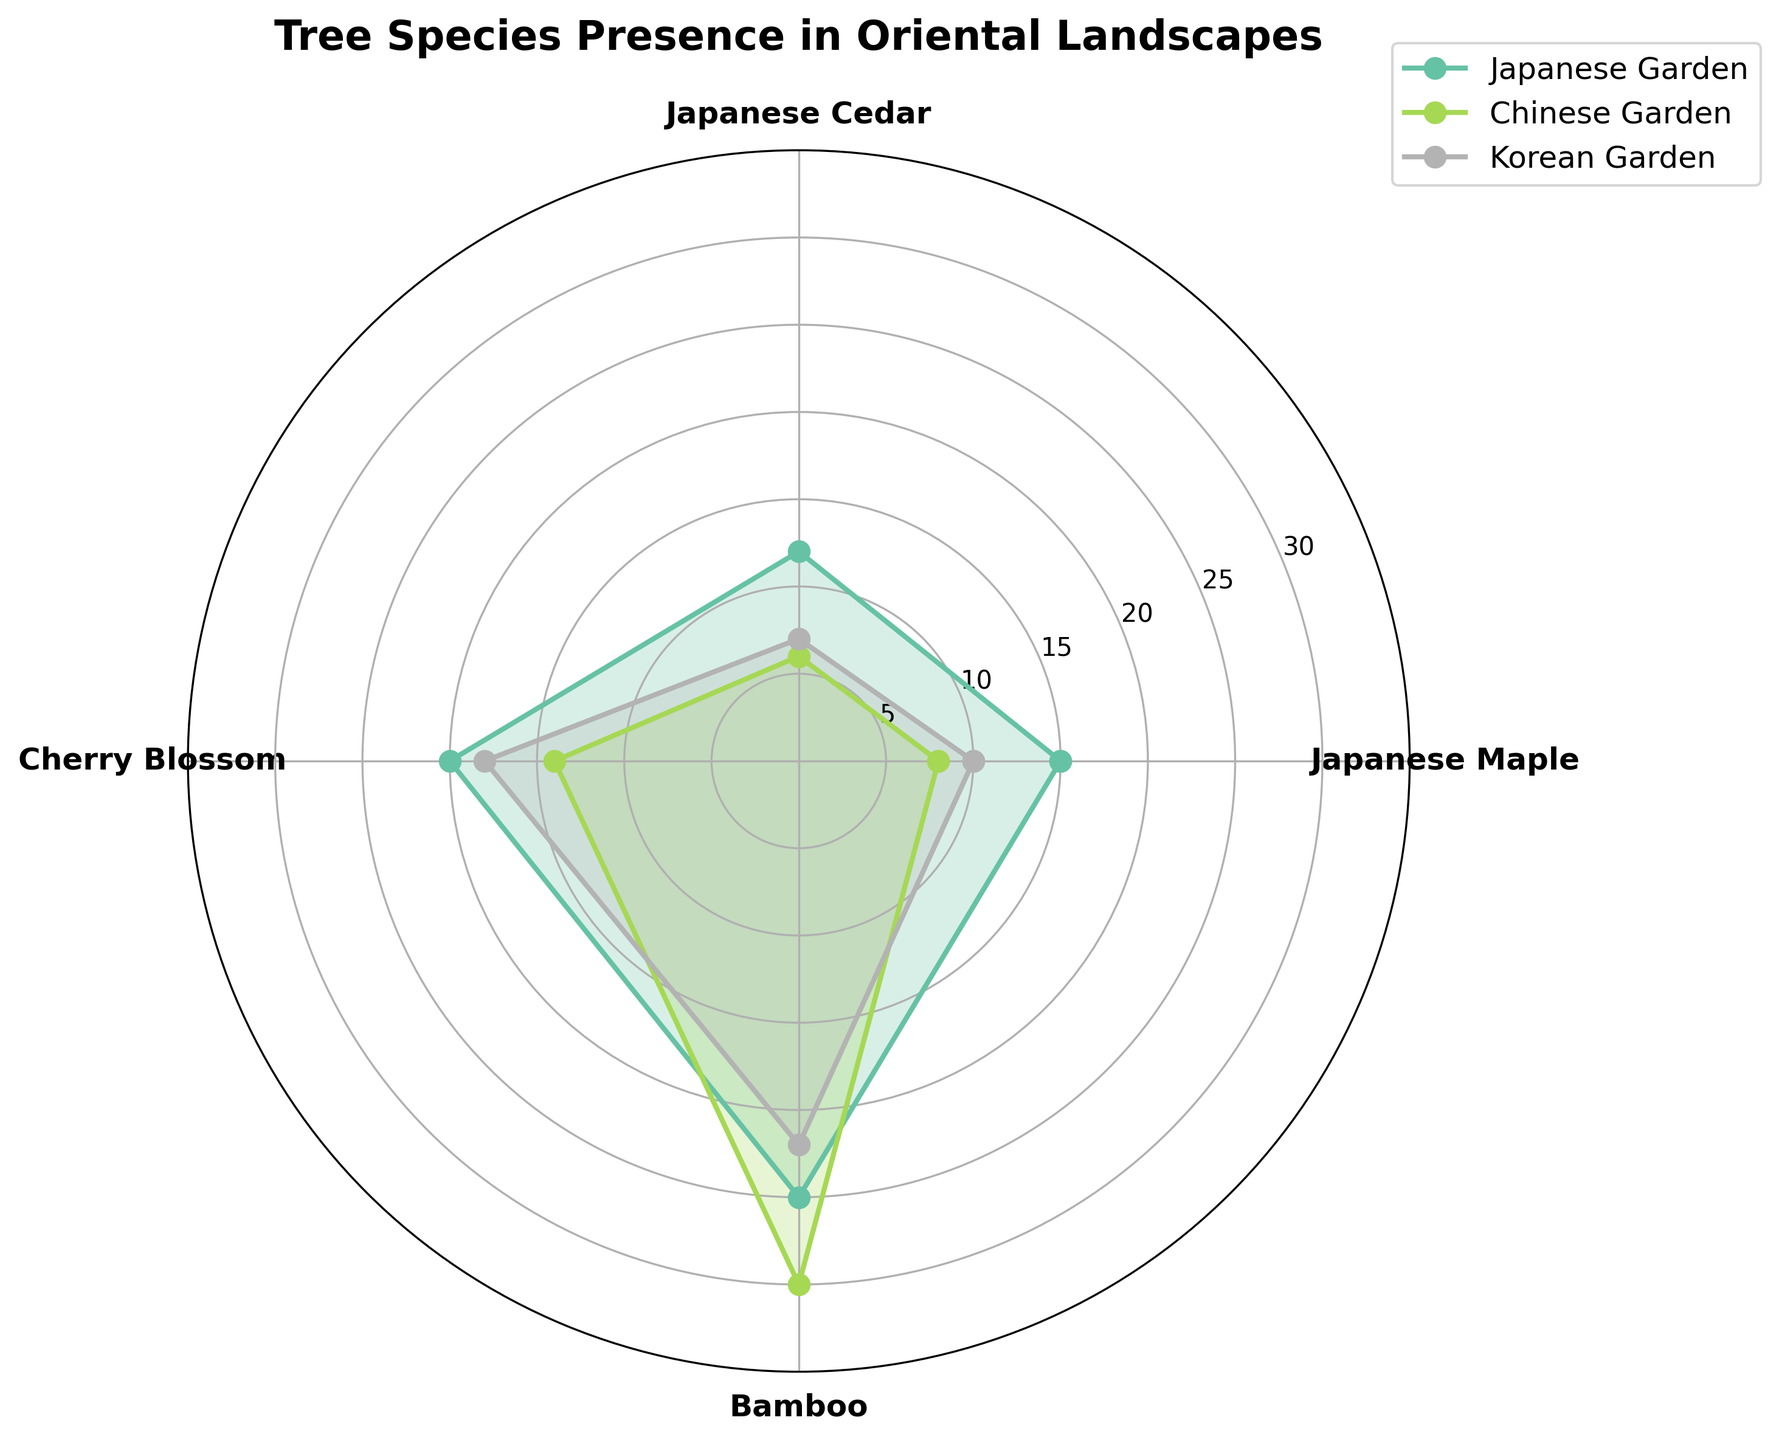How many tree species are represented in the plot? The plot shows the names of the tree species along the angular ticks. By counting these names, we see that there are four: Japanese Maple, Japanese Cedar, Cherry Blossom, and Bamboo.
Answer: 4 Which tree species has the highest count in the Chinese Garden? By examining the data for each tree species represented by the different colored lines and areas, Bamboo in the Chinese Garden has the highest count. This is indicated by the length of the radial line reaching the highest count value.
Answer: Bamboo What is the average presence of Bamboo across all landscapes? Bamboo counts are 25 in Japanese Garden, 30 in Chinese Garden, and 22 in Korean Garden. The average is calculated as (25 + 30 + 22) / 3.
Answer: 25.67 Compare the number of Cherry Blossoms in the Korean Garden to the Japanese Garden. Which garden has more, and by how much? Cherry Blossom count in the Korean Garden is 18, while in the Japanese Garden it is 20. So, Japanese Garden has 2 more Cherry Blossoms.
Answer: Japanese Garden has 2 more Which landscape has the most even distribution of tree species counts? By examining the filled areas of the segments for each landscape type, we observe that Japanese Garden shows less variation in segment lengths for different tree species, indicating a more even distribution compared to Chinese Garden and Korean Garden.
Answer: Japanese Garden How many more Japanese Maples are there in the Japanese Garden compared to the Chinese Garden? In the Japanese Garden, there are 15 Japanese Maples. In the Chinese Garden, there are 8 Japanese Maples. The difference is 15 - 8.
Answer: 7 What is the combined total of Japanese Cedars in all gardens? The counts are 12 in Japanese Garden, 6 in Chinese Garden, and 7 in Korean Garden. Combined total is 12 + 6 + 7.
Answer: 25 Did the Bamboo have the highest presence in all landscapes? By checking the radial lengths of the Bamboo segments across all three landscapes, we see that Bamboo has the highest presence counts in Chinese Garden and Korean Garden, but not in Japanese Garden where Cherry Blossom dominates with a count of 20.
Answer: No Which tree species has the least presence in the Korean Garden? The shortest radial segment within the Korean Garden (purple areas) is for Japanese Cedar, with a count of 7.
Answer: Japanese Cedar 